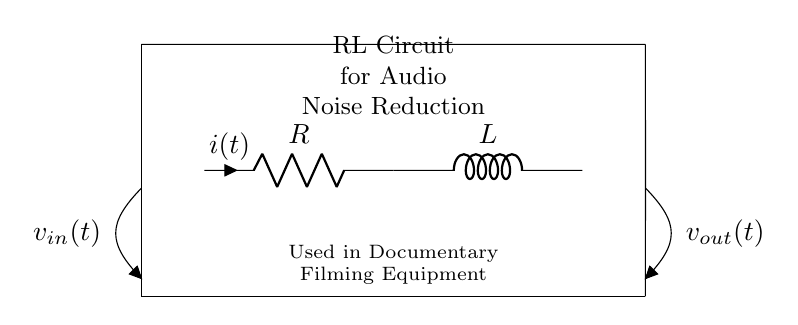What are the components of this circuit? The circuit diagram shows two main components: a resistor and an inductor. The resistor is labeled as "R" and the inductor as "L". Therefore, the components present in the circuit are a resistor and an inductor.
Answer: Resistor and Inductor What is the purpose of this RL circuit in documentary filming? The label on the circuit indicates that it is used for audio noise reduction, which is essential during documentary filming to ensure clear sound quality. This implies that the circuit serves to filter out unwanted noise in audio equipment.
Answer: Audio Noise Reduction What is the input voltage labeled in the circuit? The circuit includes an open terminal marked "v_in(t)" which represents the input voltage into the circuit. Since it is explicitly labeled in the diagram, this indicates the voltage applied at the input.
Answer: v_in(t) What is the current flowing through the resistor? The current flowing through the resistor is labeled as "i(t)" in the diagram, indicating that it is dependent on the input voltage and changes over time according to the circuit behavior.
Answer: i(t) What type of circuit is represented by the resistor and inductor? The combination of the resistor and inductor in this configuration characterizes it as an RL circuit, which specifically refers to circuits that contain both resistor and inductor elements.
Answer: RL Circuit Explain how the resistor and inductor affect audio signal quality. The resistor helps to limit the current flow, while the inductor stores energy in a magnetic field and opposes changes in current. Together, they form a filter that can attenuate certain frequencies of noise, improving overall audio quality by reducing unwanted signals.
Answer: Improve audio quality 